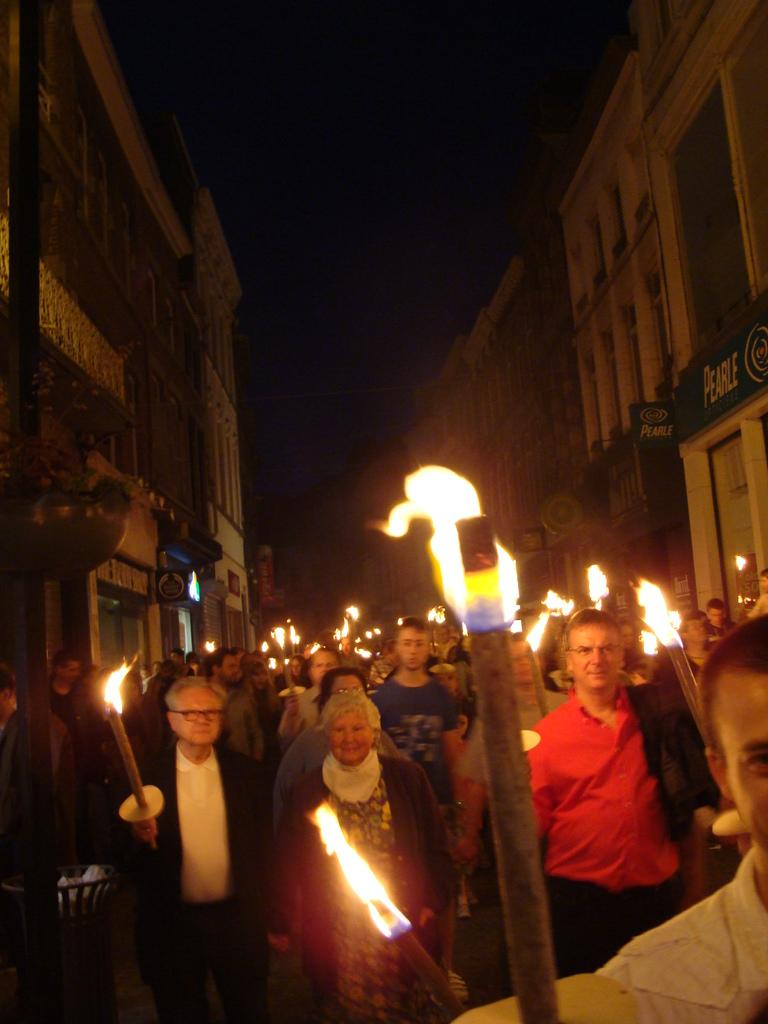What is happening in the image involving the group of people? The people are standing on the road and holding sticks with fire. What can be seen in the background of the image? There are buildings with windows visible in the background of the image. What type of vase can be seen on the side of the road in the image? There is no vase present on the side of the road in the image. What is the coil used for in the image? There is no coil present in the image. 